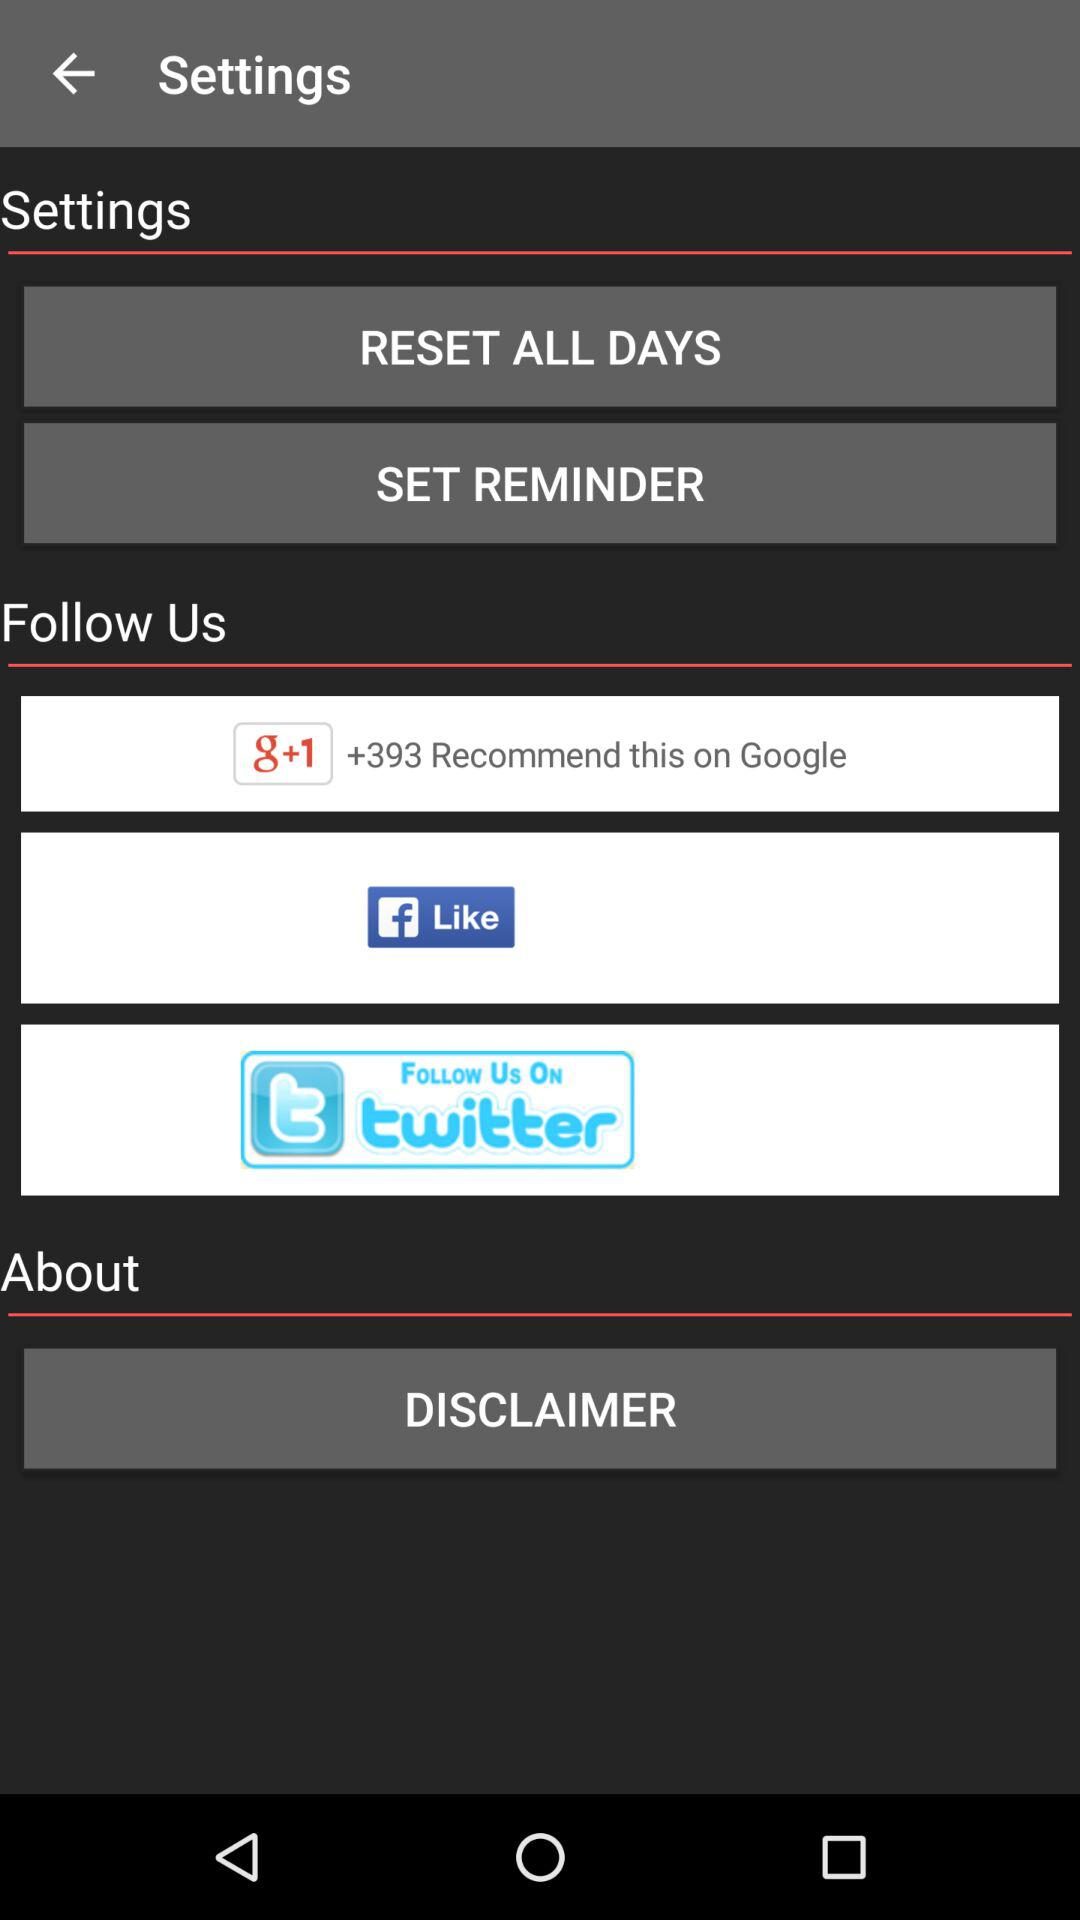What is the number of recommendations? There are more than 393 recommendations. 